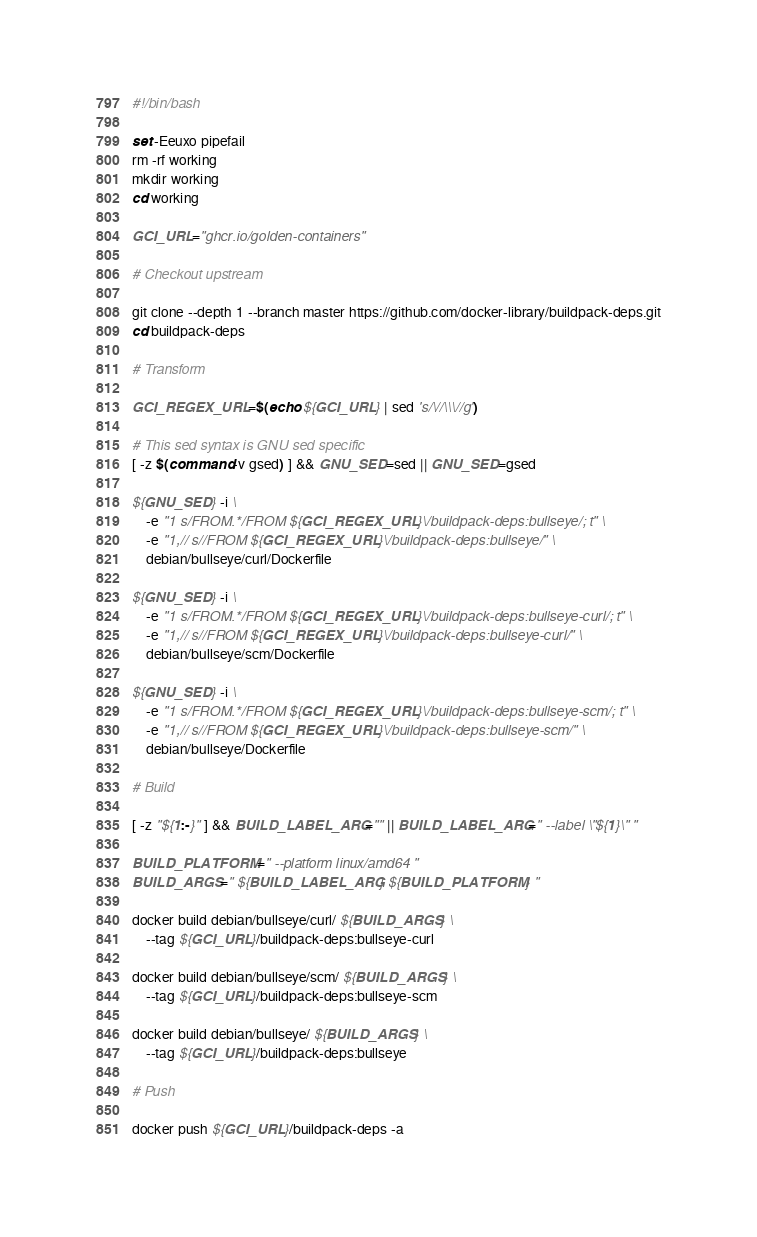<code> <loc_0><loc_0><loc_500><loc_500><_Bash_>#!/bin/bash

set -Eeuxo pipefail
rm -rf working
mkdir working
cd working

GCI_URL="ghcr.io/golden-containers"

# Checkout upstream

git clone --depth 1 --branch master https://github.com/docker-library/buildpack-deps.git
cd buildpack-deps

# Transform

GCI_REGEX_URL=$(echo ${GCI_URL} | sed 's/\//\\\//g')

# This sed syntax is GNU sed specific
[ -z $(command -v gsed) ] && GNU_SED=sed || GNU_SED=gsed

${GNU_SED} -i \
    -e "1 s/FROM.*/FROM ${GCI_REGEX_URL}\/buildpack-deps:bullseye/; t" \
    -e "1,// s//FROM ${GCI_REGEX_URL}\/buildpack-deps:bullseye/" \
    debian/bullseye/curl/Dockerfile

${GNU_SED} -i \
    -e "1 s/FROM.*/FROM ${GCI_REGEX_URL}\/buildpack-deps:bullseye-curl/; t" \
    -e "1,// s//FROM ${GCI_REGEX_URL}\/buildpack-deps:bullseye-curl/" \
    debian/bullseye/scm/Dockerfile

${GNU_SED} -i \
    -e "1 s/FROM.*/FROM ${GCI_REGEX_URL}\/buildpack-deps:bullseye-scm/; t" \
    -e "1,// s//FROM ${GCI_REGEX_URL}\/buildpack-deps:bullseye-scm/" \
    debian/bullseye/Dockerfile

# Build

[ -z "${1:-}" ] && BUILD_LABEL_ARG="" || BUILD_LABEL_ARG=" --label \"${1}\" "

BUILD_PLATFORM=" --platform linux/amd64 "
BUILD_ARGS=" ${BUILD_LABEL_ARG} ${BUILD_PLATFORM} "

docker build debian/bullseye/curl/ ${BUILD_ARGS} \
    --tag ${GCI_URL}/buildpack-deps:bullseye-curl
    
docker build debian/bullseye/scm/ ${BUILD_ARGS} \
    --tag ${GCI_URL}/buildpack-deps:bullseye-scm 
    
docker build debian/bullseye/ ${BUILD_ARGS} \
    --tag ${GCI_URL}/buildpack-deps:bullseye 
    
# Push

docker push ${GCI_URL}/buildpack-deps -a
</code> 